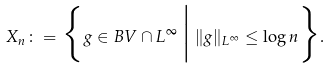Convert formula to latex. <formula><loc_0><loc_0><loc_500><loc_500>X _ { n } \colon = \Big \{ g \in B V \cap L ^ { \infty } \, \Big | \, \| g \| _ { L ^ { \infty } } \leq \log n \Big \} .</formula> 